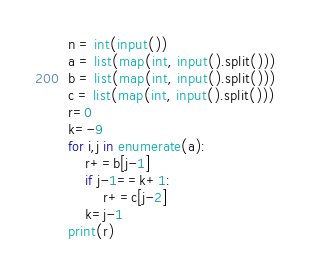Convert code to text. <code><loc_0><loc_0><loc_500><loc_500><_Python_>n = int(input())
a = list(map(int, input().split()))
b = list(map(int, input().split()))
c = list(map(int, input().split()))
r=0
k=-9
for i,j in enumerate(a):
    r+=b[j-1]
    if j-1==k+1:
        r+=c[j-2]
    k=j-1
print(r)</code> 